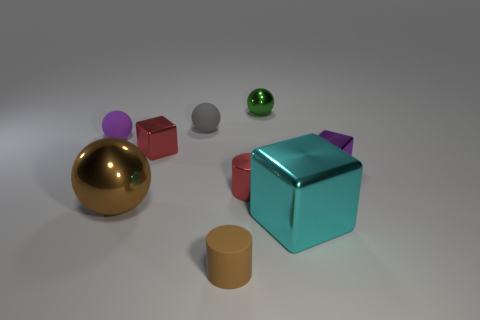Subtract all red cylinders. Subtract all purple spheres. How many cylinders are left? 1 Add 1 small metallic balls. How many objects exist? 10 Subtract all balls. How many objects are left? 5 Subtract all small green balls. Subtract all small gray spheres. How many objects are left? 7 Add 7 large objects. How many large objects are left? 9 Add 1 spheres. How many spheres exist? 5 Subtract 0 green cubes. How many objects are left? 9 